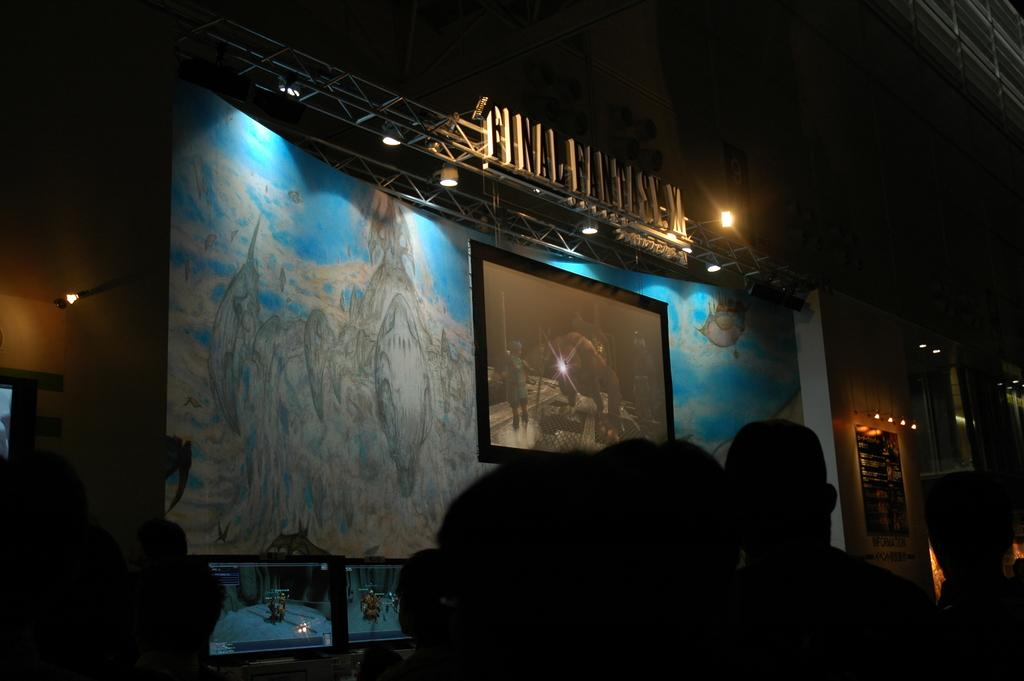What is the main feature of the image? There is a stage at the center of the image. What is being shown on the stage? A video is displayed on the stage. How are the people in the image positioned? There is a group of people sitting in front of the stage. How many legs are visible in the image? There is no specific information about legs in the image, as it focuses on the stage, video, and group of people. 